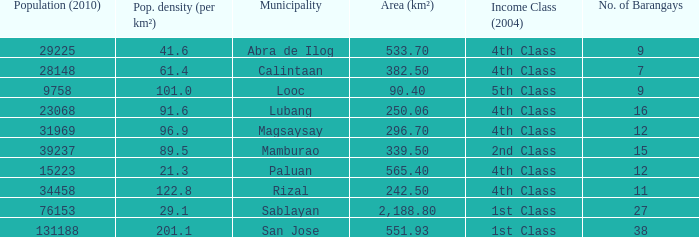What was the smallist population in 2010? 9758.0. 